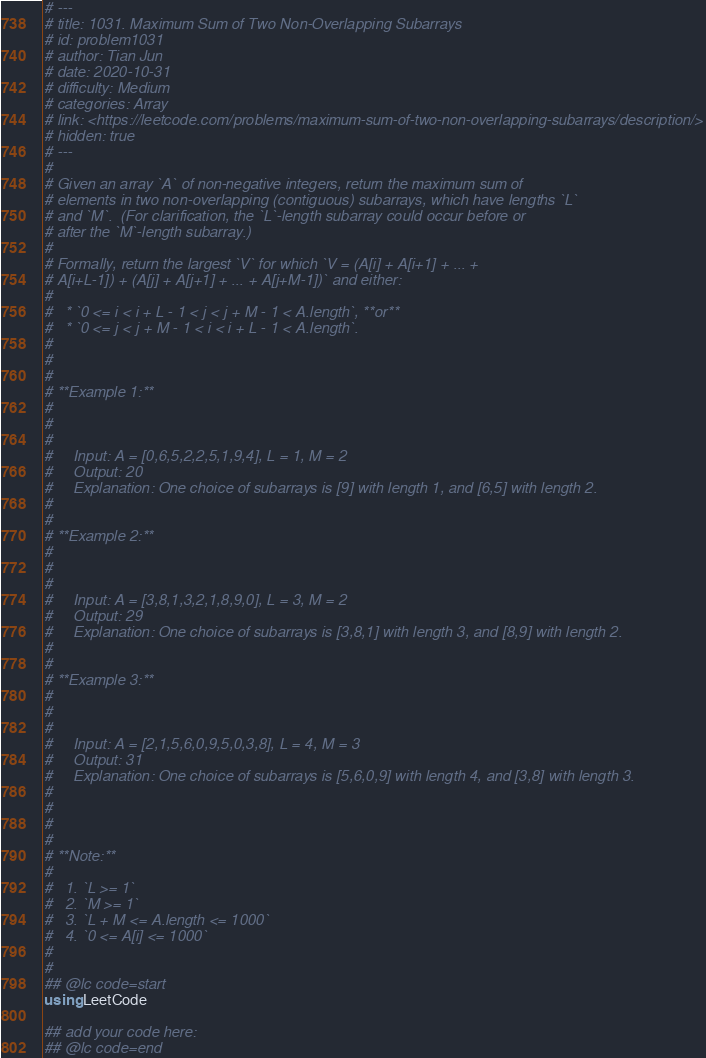Convert code to text. <code><loc_0><loc_0><loc_500><loc_500><_Julia_># ---
# title: 1031. Maximum Sum of Two Non-Overlapping Subarrays
# id: problem1031
# author: Tian Jun
# date: 2020-10-31
# difficulty: Medium
# categories: Array
# link: <https://leetcode.com/problems/maximum-sum-of-two-non-overlapping-subarrays/description/>
# hidden: true
# ---
# 
# Given an array `A` of non-negative integers, return the maximum sum of
# elements in two non-overlapping (contiguous) subarrays, which have lengths `L`
# and `M`.  (For clarification, the `L`-length subarray could occur before or
# after the `M`-length subarray.)
# 
# Formally, return the largest `V` for which `V = (A[i] + A[i+1] + ... +
# A[i+L-1]) + (A[j] + A[j+1] + ... + A[j+M-1])` and either:
# 
#   * `0 <= i < i + L - 1 < j < j + M - 1 < A.length`, **or**
#   * `0 <= j < j + M - 1 < i < i + L - 1 < A.length`.
# 
# 
# 
# **Example 1:**
# 
#     
#     
#     Input: A = [0,6,5,2,2,5,1,9,4], L = 1, M = 2
#     Output: 20
#     Explanation: One choice of subarrays is [9] with length 1, and [6,5] with length 2.
#     
# 
# **Example 2:**
# 
#     
#     
#     Input: A = [3,8,1,3,2,1,8,9,0], L = 3, M = 2
#     Output: 29
#     Explanation: One choice of subarrays is [3,8,1] with length 3, and [8,9] with length 2.
#     
# 
# **Example 3:**
# 
#     
#     
#     Input: A = [2,1,5,6,0,9,5,0,3,8], L = 4, M = 3
#     Output: 31
#     Explanation: One choice of subarrays is [5,6,0,9] with length 4, and [3,8] with length 3.
#     
# 
# 
# 
# **Note:**
# 
#   1. `L >= 1`
#   2. `M >= 1`
#   3. `L + M <= A.length <= 1000`
#   4. `0 <= A[i] <= 1000`
# 
# 
## @lc code=start
using LeetCode

## add your code here:
## @lc code=end
</code> 